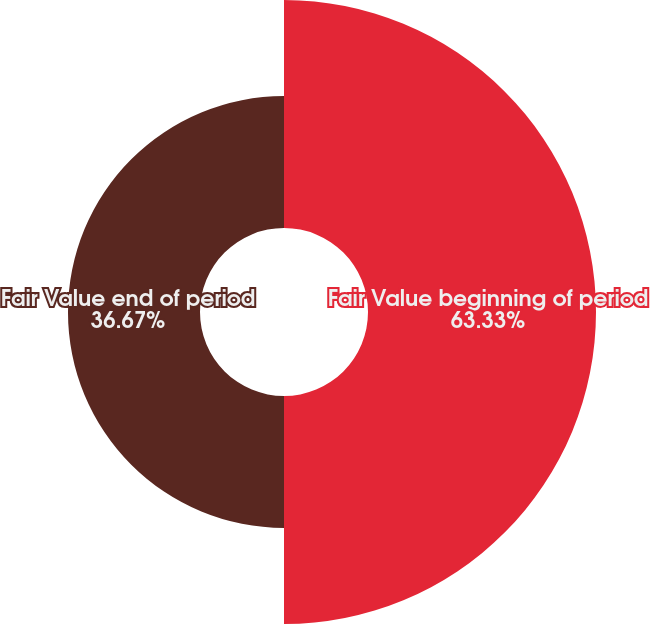Convert chart. <chart><loc_0><loc_0><loc_500><loc_500><pie_chart><fcel>Fair Value beginning of period<fcel>Fair Value end of period<nl><fcel>63.33%<fcel>36.67%<nl></chart> 